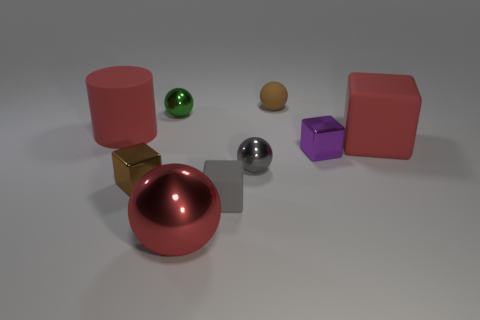Add 1 tiny rubber cubes. How many objects exist? 10 Subtract all cubes. How many objects are left? 5 Add 7 big red shiny things. How many big red shiny things are left? 8 Add 2 big red matte cylinders. How many big red matte cylinders exist? 3 Subtract 0 brown cylinders. How many objects are left? 9 Subtract all small blocks. Subtract all purple cubes. How many objects are left? 5 